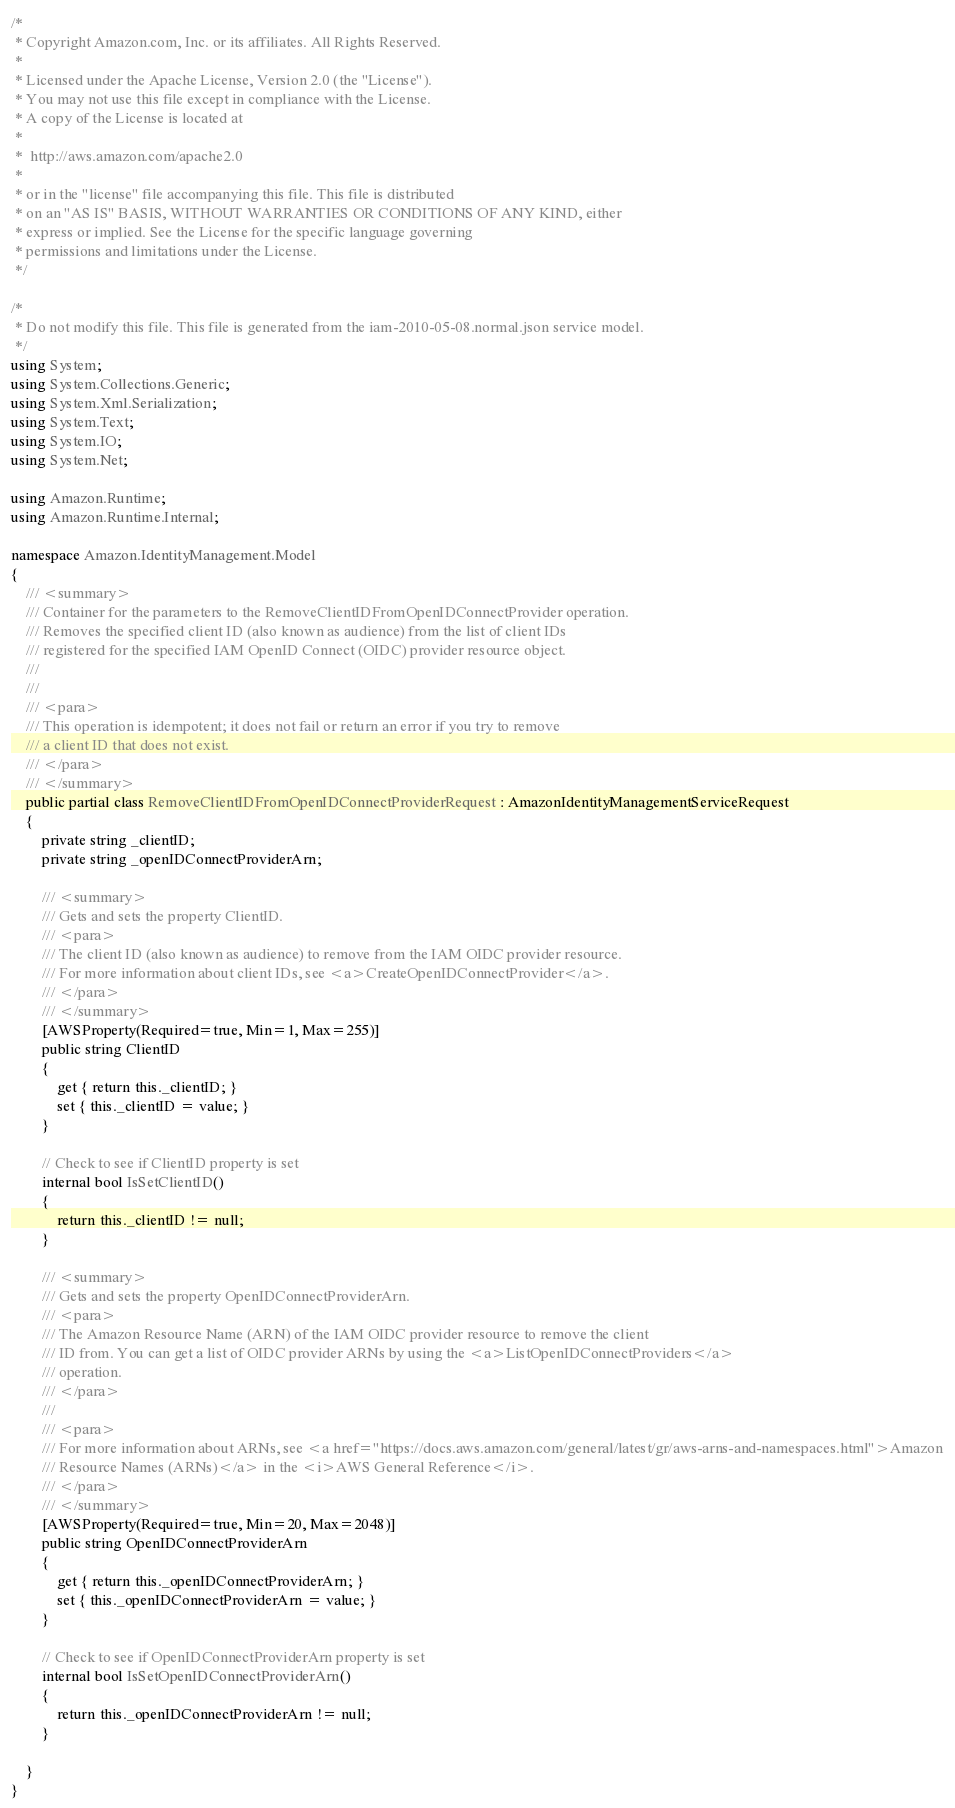<code> <loc_0><loc_0><loc_500><loc_500><_C#_>/*
 * Copyright Amazon.com, Inc. or its affiliates. All Rights Reserved.
 * 
 * Licensed under the Apache License, Version 2.0 (the "License").
 * You may not use this file except in compliance with the License.
 * A copy of the License is located at
 * 
 *  http://aws.amazon.com/apache2.0
 * 
 * or in the "license" file accompanying this file. This file is distributed
 * on an "AS IS" BASIS, WITHOUT WARRANTIES OR CONDITIONS OF ANY KIND, either
 * express or implied. See the License for the specific language governing
 * permissions and limitations under the License.
 */

/*
 * Do not modify this file. This file is generated from the iam-2010-05-08.normal.json service model.
 */
using System;
using System.Collections.Generic;
using System.Xml.Serialization;
using System.Text;
using System.IO;
using System.Net;

using Amazon.Runtime;
using Amazon.Runtime.Internal;

namespace Amazon.IdentityManagement.Model
{
    /// <summary>
    /// Container for the parameters to the RemoveClientIDFromOpenIDConnectProvider operation.
    /// Removes the specified client ID (also known as audience) from the list of client IDs
    /// registered for the specified IAM OpenID Connect (OIDC) provider resource object.
    /// 
    ///  
    /// <para>
    /// This operation is idempotent; it does not fail or return an error if you try to remove
    /// a client ID that does not exist.
    /// </para>
    /// </summary>
    public partial class RemoveClientIDFromOpenIDConnectProviderRequest : AmazonIdentityManagementServiceRequest
    {
        private string _clientID;
        private string _openIDConnectProviderArn;

        /// <summary>
        /// Gets and sets the property ClientID. 
        /// <para>
        /// The client ID (also known as audience) to remove from the IAM OIDC provider resource.
        /// For more information about client IDs, see <a>CreateOpenIDConnectProvider</a>.
        /// </para>
        /// </summary>
        [AWSProperty(Required=true, Min=1, Max=255)]
        public string ClientID
        {
            get { return this._clientID; }
            set { this._clientID = value; }
        }

        // Check to see if ClientID property is set
        internal bool IsSetClientID()
        {
            return this._clientID != null;
        }

        /// <summary>
        /// Gets and sets the property OpenIDConnectProviderArn. 
        /// <para>
        /// The Amazon Resource Name (ARN) of the IAM OIDC provider resource to remove the client
        /// ID from. You can get a list of OIDC provider ARNs by using the <a>ListOpenIDConnectProviders</a>
        /// operation.
        /// </para>
        ///  
        /// <para>
        /// For more information about ARNs, see <a href="https://docs.aws.amazon.com/general/latest/gr/aws-arns-and-namespaces.html">Amazon
        /// Resource Names (ARNs)</a> in the <i>AWS General Reference</i>.
        /// </para>
        /// </summary>
        [AWSProperty(Required=true, Min=20, Max=2048)]
        public string OpenIDConnectProviderArn
        {
            get { return this._openIDConnectProviderArn; }
            set { this._openIDConnectProviderArn = value; }
        }

        // Check to see if OpenIDConnectProviderArn property is set
        internal bool IsSetOpenIDConnectProviderArn()
        {
            return this._openIDConnectProviderArn != null;
        }

    }
}</code> 